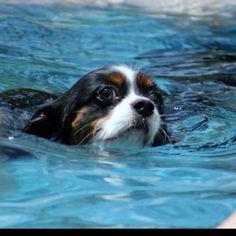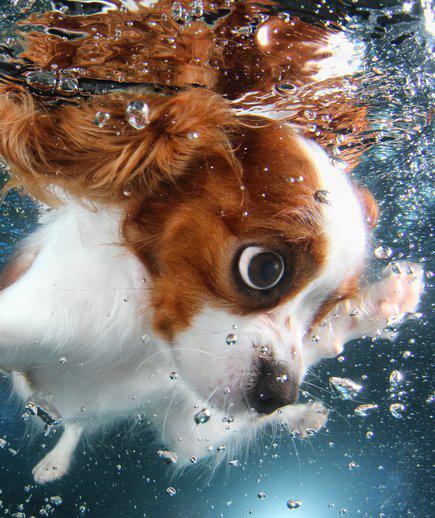The first image is the image on the left, the second image is the image on the right. Examine the images to the left and right. Is the description "There is a dog swimming in each image." accurate? Answer yes or no. Yes. The first image is the image on the left, the second image is the image on the right. Assess this claim about the two images: "The righthand image shows a spaniel with a natural body of water, and the lefthand shows a spaniel in pool water.". Correct or not? Answer yes or no. No. 